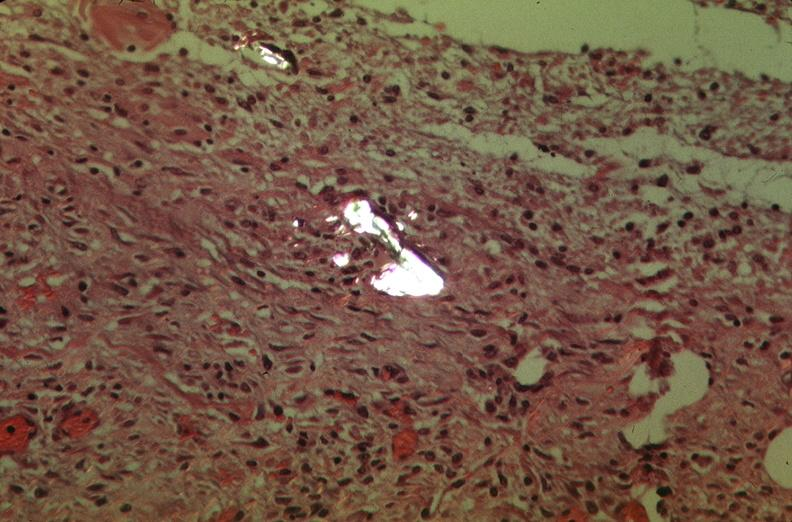s respiratory present?
Answer the question using a single word or phrase. Yes 